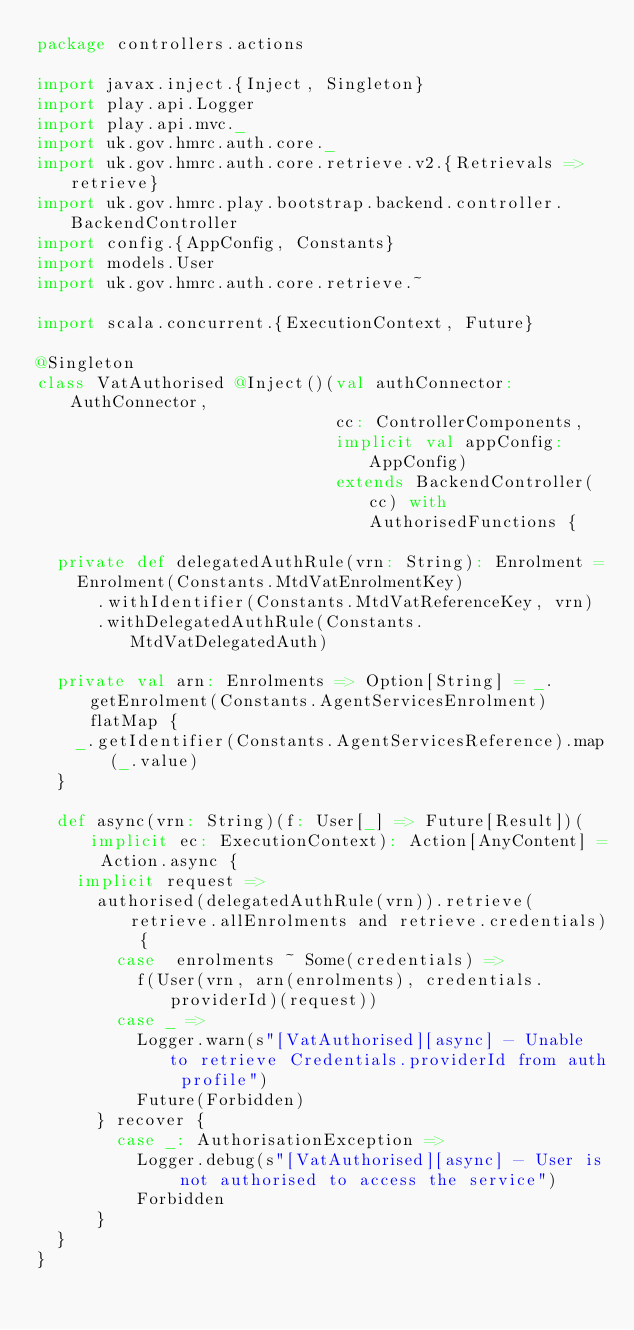Convert code to text. <code><loc_0><loc_0><loc_500><loc_500><_Scala_>package controllers.actions

import javax.inject.{Inject, Singleton}
import play.api.Logger
import play.api.mvc._
import uk.gov.hmrc.auth.core._
import uk.gov.hmrc.auth.core.retrieve.v2.{Retrievals => retrieve}
import uk.gov.hmrc.play.bootstrap.backend.controller.BackendController
import config.{AppConfig, Constants}
import models.User
import uk.gov.hmrc.auth.core.retrieve.~

import scala.concurrent.{ExecutionContext, Future}

@Singleton
class VatAuthorised @Inject()(val authConnector: AuthConnector,
                              cc: ControllerComponents,
                              implicit val appConfig: AppConfig)
                              extends BackendController(cc) with AuthorisedFunctions {

  private def delegatedAuthRule(vrn: String): Enrolment =
    Enrolment(Constants.MtdVatEnrolmentKey)
      .withIdentifier(Constants.MtdVatReferenceKey, vrn)
      .withDelegatedAuthRule(Constants.MtdVatDelegatedAuth)

  private val arn: Enrolments => Option[String] = _.getEnrolment(Constants.AgentServicesEnrolment) flatMap {
    _.getIdentifier(Constants.AgentServicesReference).map(_.value)
  }

  def async(vrn: String)(f: User[_] => Future[Result])(implicit ec: ExecutionContext): Action[AnyContent] = Action.async {
    implicit request =>
      authorised(delegatedAuthRule(vrn)).retrieve(retrieve.allEnrolments and retrieve.credentials) {
        case  enrolments ~ Some(credentials) =>
          f(User(vrn, arn(enrolments), credentials.providerId)(request))
        case _ =>
          Logger.warn(s"[VatAuthorised][async] - Unable to retrieve Credentials.providerId from auth profile")
          Future(Forbidden)
      } recover {
        case _: AuthorisationException =>
          Logger.debug(s"[VatAuthorised][async] - User is not authorised to access the service")
          Forbidden
      }
  }
}

</code> 